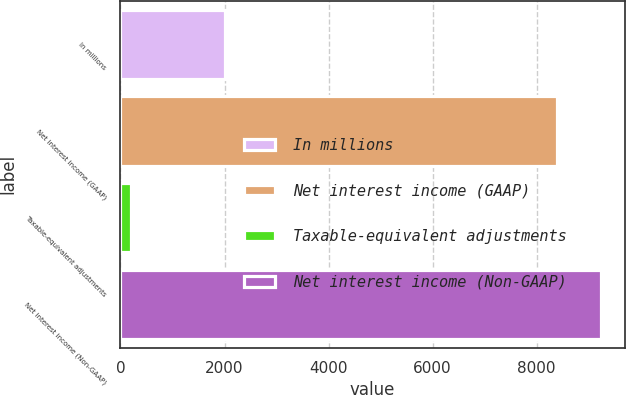<chart> <loc_0><loc_0><loc_500><loc_500><bar_chart><fcel>In millions<fcel>Net interest income (GAAP)<fcel>Taxable-equivalent adjustments<fcel>Net interest income (Non-GAAP)<nl><fcel>2016<fcel>8391<fcel>195<fcel>9230.1<nl></chart> 